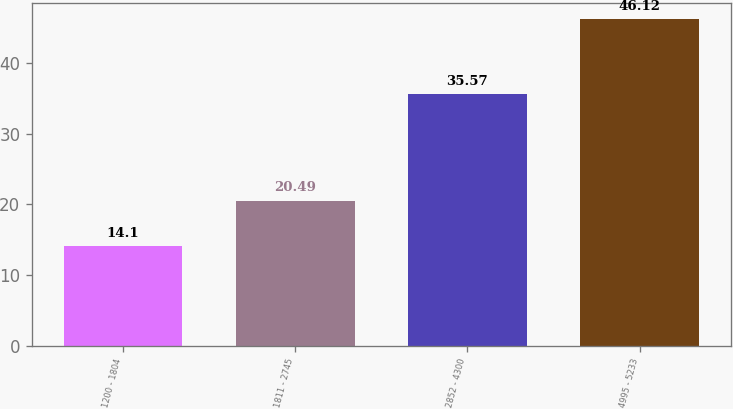<chart> <loc_0><loc_0><loc_500><loc_500><bar_chart><fcel>1200 - 1804<fcel>1811 - 2745<fcel>2852 - 4300<fcel>4995 - 5233<nl><fcel>14.1<fcel>20.49<fcel>35.57<fcel>46.12<nl></chart> 